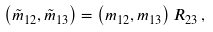Convert formula to latex. <formula><loc_0><loc_0><loc_500><loc_500>\left ( \tilde { m } _ { 1 2 } , \tilde { m } _ { 1 3 } \right ) = \left ( m _ { 1 2 } , m _ { 1 3 } \right ) R _ { 2 3 } \, ,</formula> 